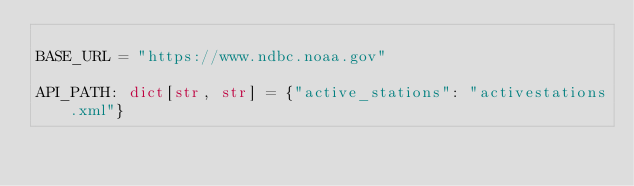Convert code to text. <code><loc_0><loc_0><loc_500><loc_500><_Python_>
BASE_URL = "https://www.ndbc.noaa.gov"

API_PATH: dict[str, str] = {"active_stations": "activestations.xml"}
</code> 